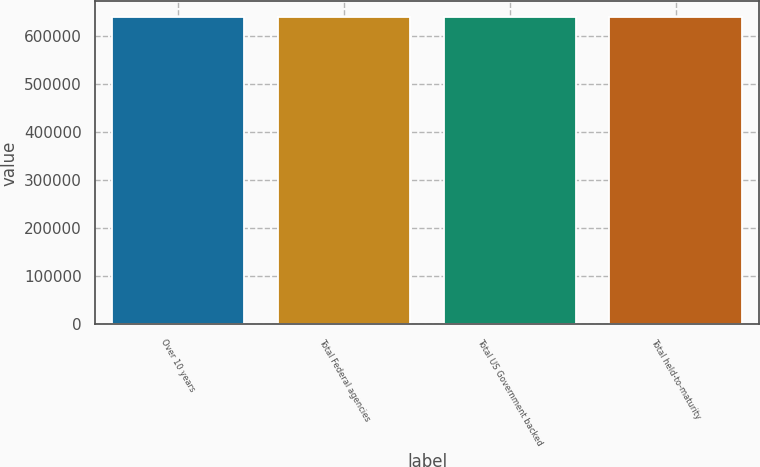<chart> <loc_0><loc_0><loc_500><loc_500><bar_chart><fcel>Over 10 years<fcel>Total Federal agencies<fcel>Total US Government backed<fcel>Total held-to-maturity<nl><fcel>640551<fcel>640551<fcel>640551<fcel>640551<nl></chart> 